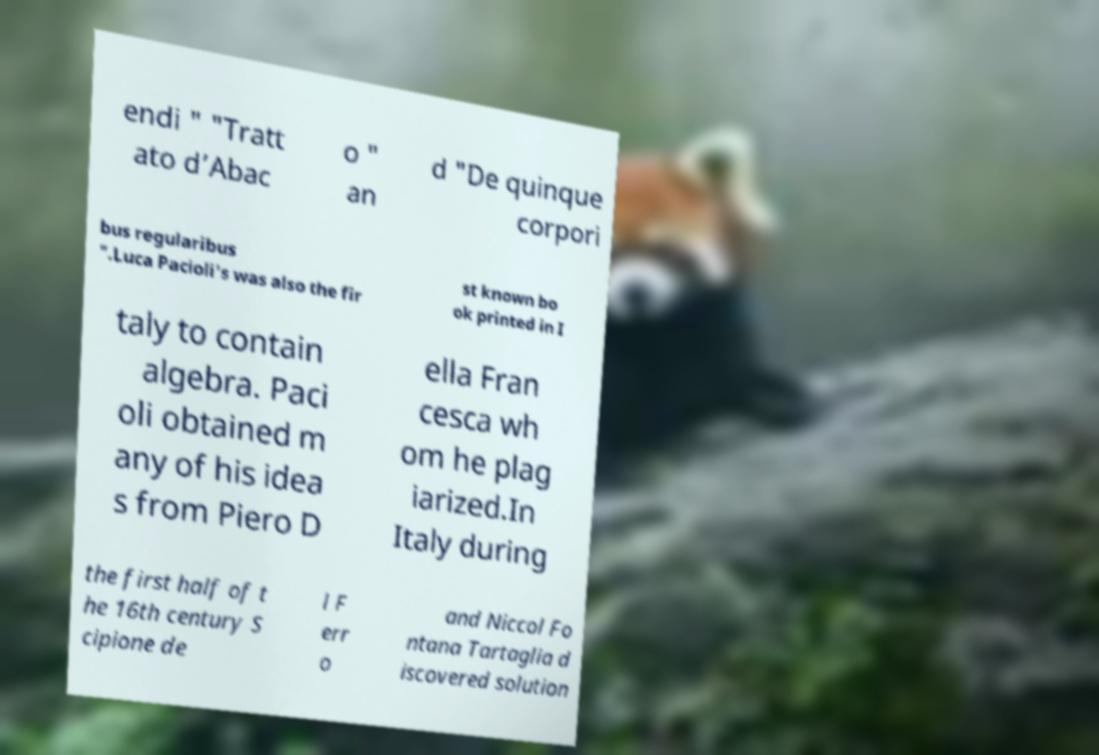For documentation purposes, I need the text within this image transcribed. Could you provide that? endi " "Tratt ato d’Abac o " an d "De quinque corpori bus regularibus ".Luca Pacioli's was also the fir st known bo ok printed in I taly to contain algebra. Paci oli obtained m any of his idea s from Piero D ella Fran cesca wh om he plag iarized.In Italy during the first half of t he 16th century S cipione de l F err o and Niccol Fo ntana Tartaglia d iscovered solution 